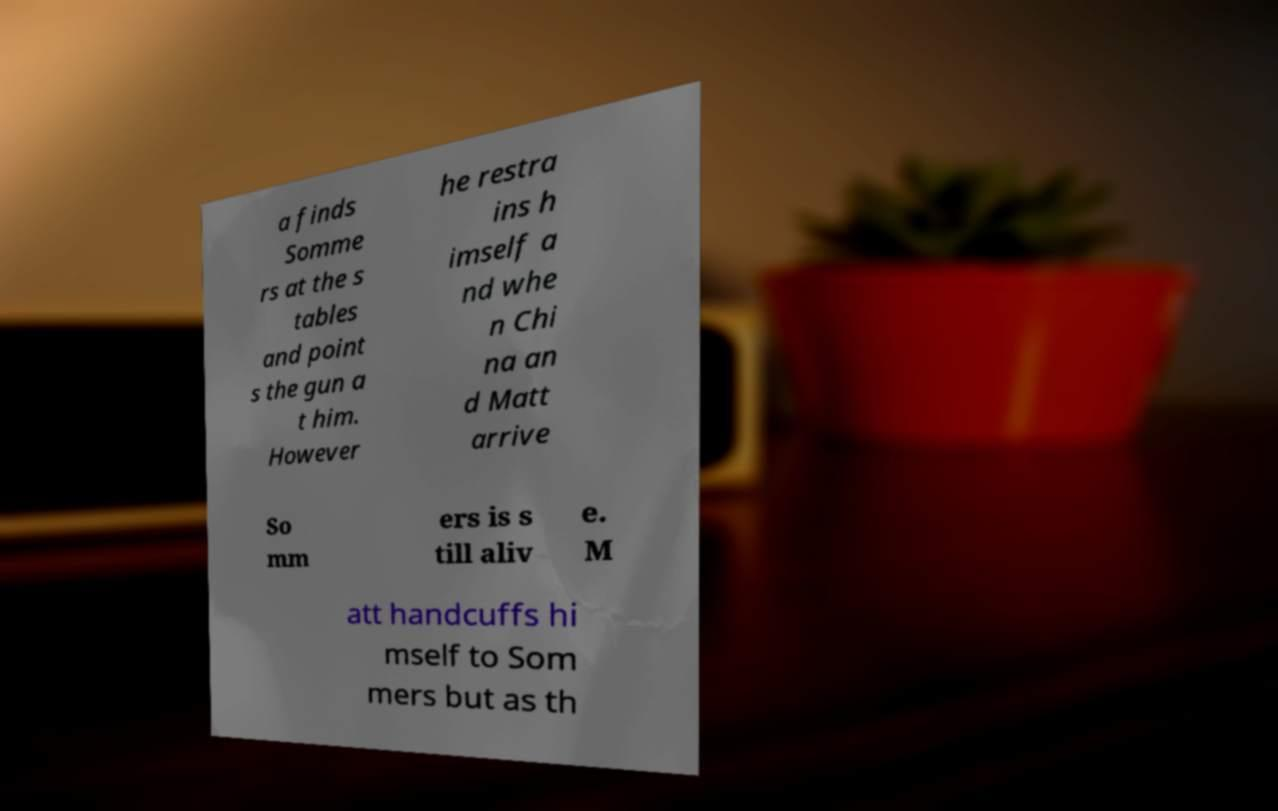Could you extract and type out the text from this image? a finds Somme rs at the s tables and point s the gun a t him. However he restra ins h imself a nd whe n Chi na an d Matt arrive So mm ers is s till aliv e. M att handcuffs hi mself to Som mers but as th 